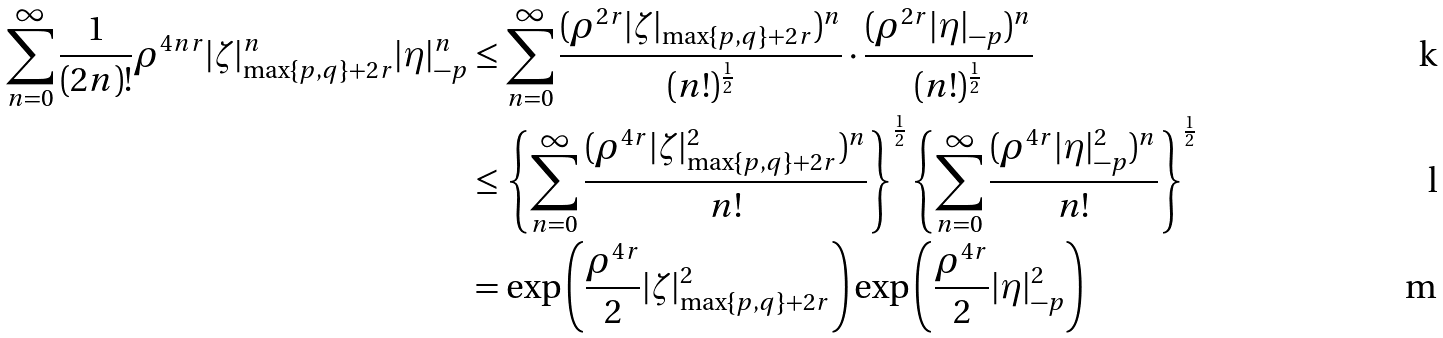Convert formula to latex. <formula><loc_0><loc_0><loc_500><loc_500>\sum _ { n = 0 } ^ { \infty } \frac { 1 } { ( 2 n ) ! } \rho ^ { 4 n r } | \zeta | _ { \max \{ p , q \} + 2 r } ^ { n } | \eta | _ { - p } ^ { n } & \leq \sum _ { n = 0 } ^ { \infty } \frac { ( \rho ^ { 2 r } | \zeta | _ { \max \{ p , q \} + 2 r } ) ^ { n } } { ( n ! ) ^ { \frac { 1 } { 2 } } } \cdot \frac { ( \rho ^ { 2 r } | \eta | _ { - p } ) ^ { n } } { ( n ! ) ^ { \frac { 1 } { 2 } } } \\ & \leq \left \{ \sum _ { n = 0 } ^ { \infty } \frac { ( \rho ^ { 4 r } | \zeta | _ { \max \{ p , q \} + 2 r } ^ { 2 } ) ^ { n } } { n ! } \right \} ^ { \frac { 1 } { 2 } } \left \{ \sum _ { n = 0 } ^ { \infty } \frac { ( \rho ^ { 4 r } | \eta | _ { - p } ^ { 2 } ) ^ { n } } { n ! } \right \} ^ { \frac { 1 } { 2 } } \\ & = \exp \left ( \frac { \rho ^ { 4 r } } { 2 } | \zeta | _ { \max \{ p , q \} + 2 r } ^ { 2 } \right ) \exp \left ( \frac { \rho ^ { 4 r } } { 2 } | \eta | _ { - p } ^ { 2 } \right )</formula> 